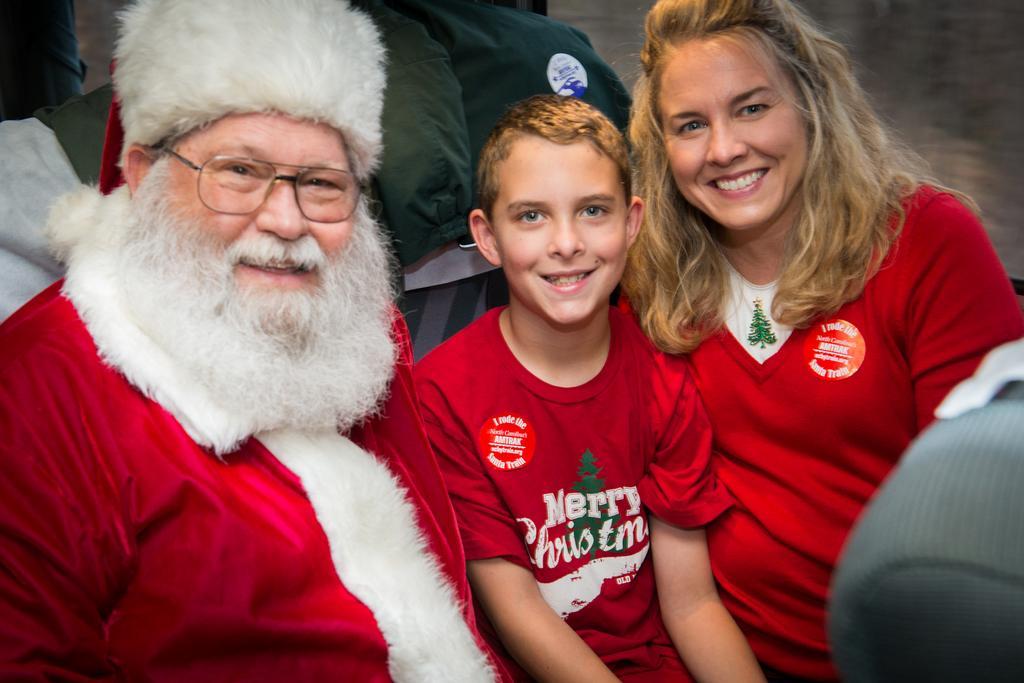In one or two sentences, can you explain what this image depicts? In this image there is a person wearing spectacles and a cap. Beside him there is a boy. Right side there is a woman. There are people sitting on the bench. 